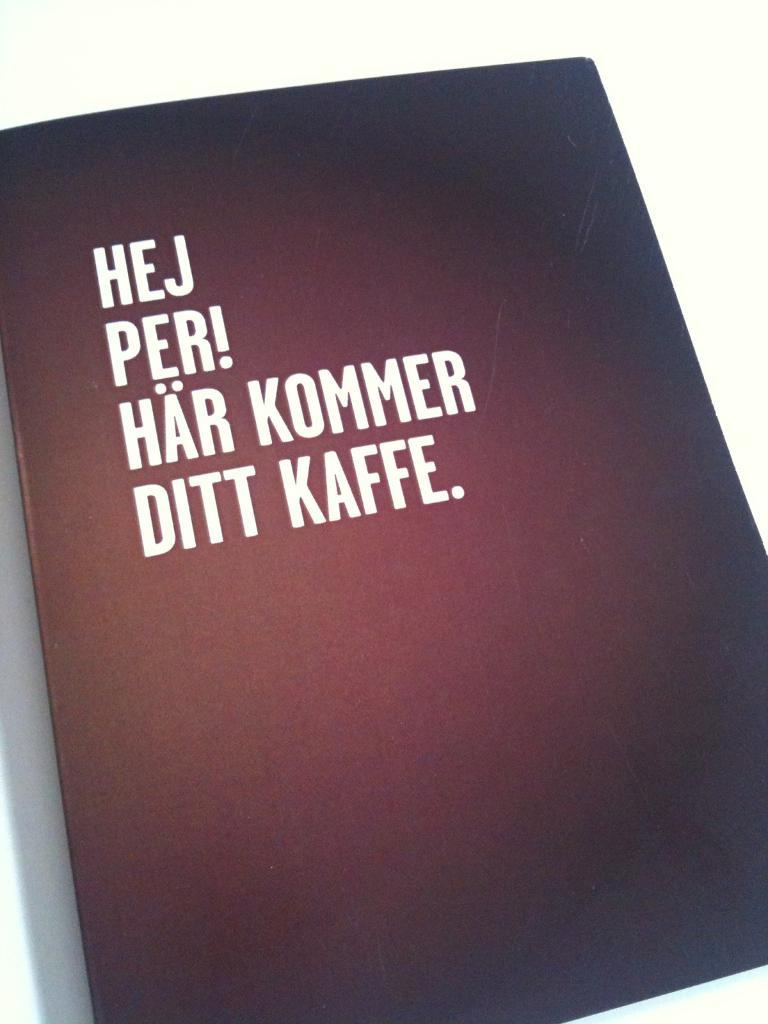Provide a one-sentence caption for the provided image. a black book with Hej Per! Har Kommer Ditt Kaffe on it. 